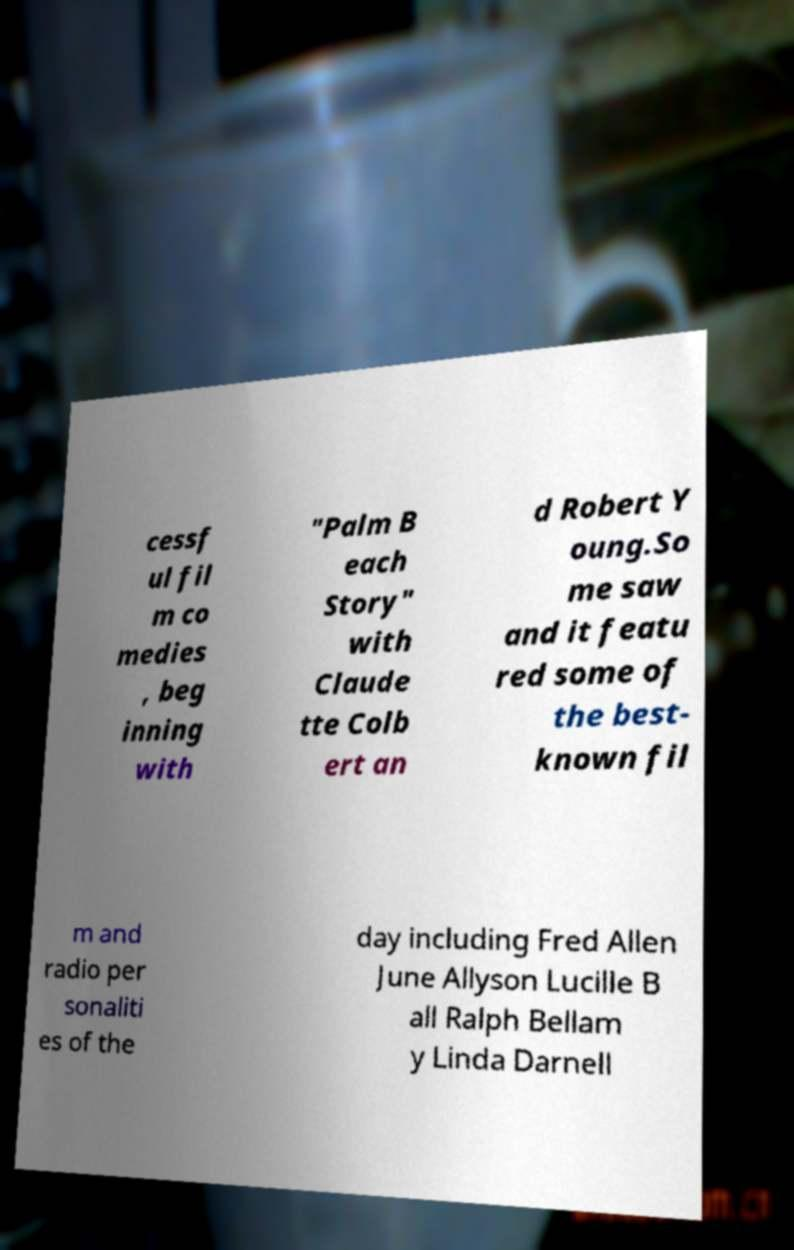Please identify and transcribe the text found in this image. cessf ul fil m co medies , beg inning with "Palm B each Story" with Claude tte Colb ert an d Robert Y oung.So me saw and it featu red some of the best- known fil m and radio per sonaliti es of the day including Fred Allen June Allyson Lucille B all Ralph Bellam y Linda Darnell 